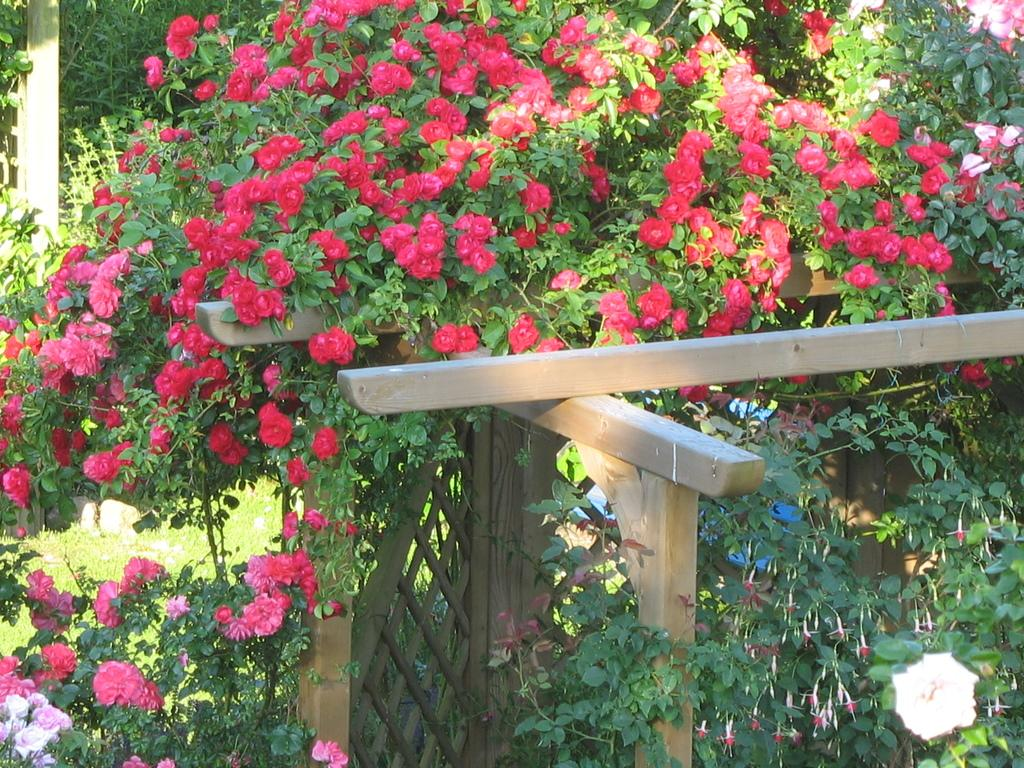What type of area is depicted in the image? There is a garden in the image. What can be found in the garden? The garden contains plants with flowers and other plants with small flowers. Is there any structure or feature in the garden? Yes, there is a wooden fence in the middle of the garden. What type of ship can be seen sailing through the garden in the image? There is no ship present in the image; it is a garden with plants and flowers. 